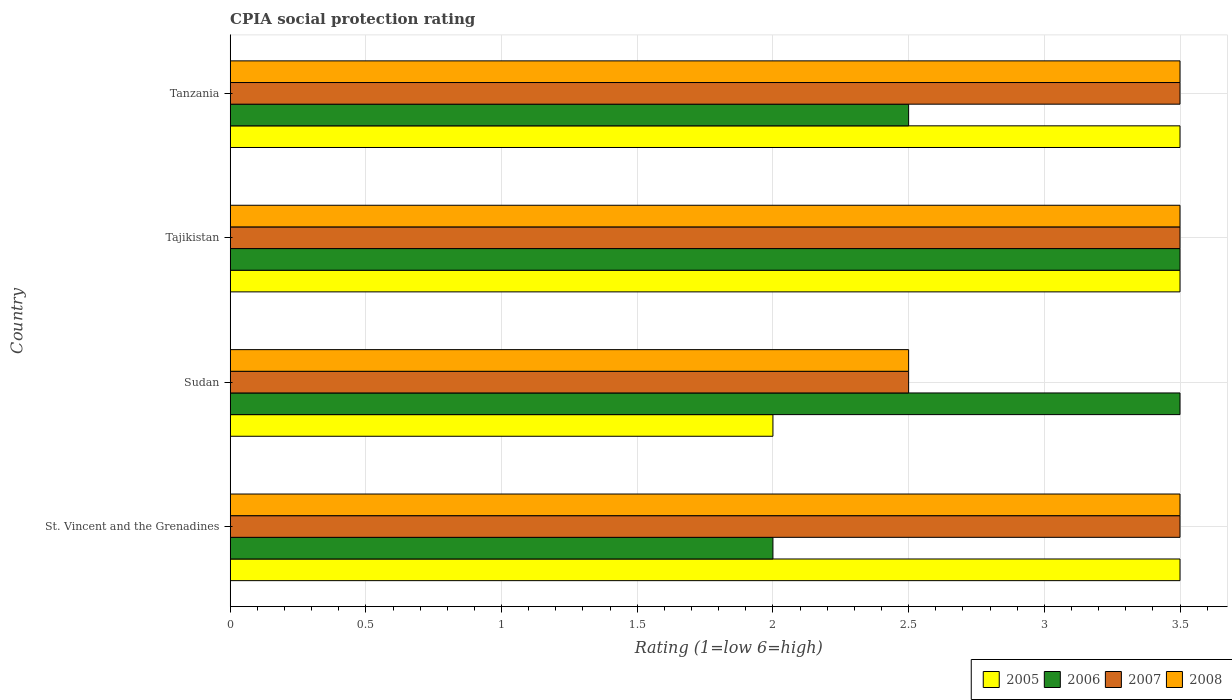How many different coloured bars are there?
Make the answer very short. 4. How many groups of bars are there?
Your response must be concise. 4. How many bars are there on the 2nd tick from the bottom?
Your response must be concise. 4. What is the label of the 3rd group of bars from the top?
Give a very brief answer. Sudan. What is the CPIA rating in 2007 in St. Vincent and the Grenadines?
Offer a very short reply. 3.5. In which country was the CPIA rating in 2008 maximum?
Your answer should be compact. St. Vincent and the Grenadines. In which country was the CPIA rating in 2008 minimum?
Keep it short and to the point. Sudan. What is the total CPIA rating in 2006 in the graph?
Provide a succinct answer. 11.5. What is the difference between the CPIA rating in 2006 in Tanzania and the CPIA rating in 2007 in St. Vincent and the Grenadines?
Provide a succinct answer. -1. What is the average CPIA rating in 2005 per country?
Give a very brief answer. 3.12. What is the difference between the CPIA rating in 2008 and CPIA rating in 2005 in Sudan?
Ensure brevity in your answer.  0.5. In how many countries, is the CPIA rating in 2006 greater than 0.1 ?
Your answer should be very brief. 4. What is the ratio of the CPIA rating in 2006 in Sudan to that in Tanzania?
Offer a very short reply. 1.4. Is the CPIA rating in 2006 in Sudan less than that in Tajikistan?
Provide a succinct answer. No. What is the difference between the highest and the second highest CPIA rating in 2007?
Your answer should be very brief. 0. What is the difference between the highest and the lowest CPIA rating in 2005?
Your response must be concise. 1.5. In how many countries, is the CPIA rating in 2007 greater than the average CPIA rating in 2007 taken over all countries?
Your response must be concise. 3. Is the sum of the CPIA rating in 2005 in St. Vincent and the Grenadines and Sudan greater than the maximum CPIA rating in 2008 across all countries?
Provide a succinct answer. Yes. Is it the case that in every country, the sum of the CPIA rating in 2006 and CPIA rating in 2005 is greater than the sum of CPIA rating in 2007 and CPIA rating in 2008?
Provide a succinct answer. No. Are all the bars in the graph horizontal?
Offer a terse response. Yes. Does the graph contain grids?
Keep it short and to the point. Yes. How are the legend labels stacked?
Provide a short and direct response. Horizontal. What is the title of the graph?
Ensure brevity in your answer.  CPIA social protection rating. What is the label or title of the X-axis?
Ensure brevity in your answer.  Rating (1=low 6=high). What is the label or title of the Y-axis?
Your answer should be very brief. Country. What is the Rating (1=low 6=high) of 2006 in St. Vincent and the Grenadines?
Offer a terse response. 2. What is the Rating (1=low 6=high) of 2007 in St. Vincent and the Grenadines?
Your answer should be very brief. 3.5. What is the Rating (1=low 6=high) in 2008 in St. Vincent and the Grenadines?
Provide a short and direct response. 3.5. What is the Rating (1=low 6=high) of 2005 in Sudan?
Your answer should be very brief. 2. What is the Rating (1=low 6=high) of 2006 in Sudan?
Ensure brevity in your answer.  3.5. What is the Rating (1=low 6=high) of 2006 in Tajikistan?
Provide a succinct answer. 3.5. What is the Rating (1=low 6=high) in 2007 in Tajikistan?
Make the answer very short. 3.5. What is the Rating (1=low 6=high) of 2008 in Tajikistan?
Your answer should be compact. 3.5. What is the Rating (1=low 6=high) in 2005 in Tanzania?
Provide a succinct answer. 3.5. Across all countries, what is the maximum Rating (1=low 6=high) of 2008?
Provide a succinct answer. 3.5. Across all countries, what is the minimum Rating (1=low 6=high) in 2005?
Your answer should be very brief. 2. What is the total Rating (1=low 6=high) of 2006 in the graph?
Make the answer very short. 11.5. What is the total Rating (1=low 6=high) of 2007 in the graph?
Your answer should be compact. 13. What is the total Rating (1=low 6=high) of 2008 in the graph?
Your response must be concise. 13. What is the difference between the Rating (1=low 6=high) in 2005 in St. Vincent and the Grenadines and that in Sudan?
Offer a very short reply. 1.5. What is the difference between the Rating (1=low 6=high) in 2006 in St. Vincent and the Grenadines and that in Sudan?
Your answer should be very brief. -1.5. What is the difference between the Rating (1=low 6=high) of 2007 in St. Vincent and the Grenadines and that in Sudan?
Make the answer very short. 1. What is the difference between the Rating (1=low 6=high) in 2007 in St. Vincent and the Grenadines and that in Tajikistan?
Give a very brief answer. 0. What is the difference between the Rating (1=low 6=high) in 2007 in St. Vincent and the Grenadines and that in Tanzania?
Ensure brevity in your answer.  0. What is the difference between the Rating (1=low 6=high) of 2005 in Sudan and that in Tajikistan?
Provide a succinct answer. -1.5. What is the difference between the Rating (1=low 6=high) in 2007 in Sudan and that in Tajikistan?
Give a very brief answer. -1. What is the difference between the Rating (1=low 6=high) of 2005 in Sudan and that in Tanzania?
Your answer should be compact. -1.5. What is the difference between the Rating (1=low 6=high) of 2005 in St. Vincent and the Grenadines and the Rating (1=low 6=high) of 2008 in Sudan?
Offer a very short reply. 1. What is the difference between the Rating (1=low 6=high) in 2006 in St. Vincent and the Grenadines and the Rating (1=low 6=high) in 2007 in Sudan?
Your response must be concise. -0.5. What is the difference between the Rating (1=low 6=high) of 2006 in St. Vincent and the Grenadines and the Rating (1=low 6=high) of 2008 in Sudan?
Your answer should be compact. -0.5. What is the difference between the Rating (1=low 6=high) of 2005 in St. Vincent and the Grenadines and the Rating (1=low 6=high) of 2006 in Tajikistan?
Your response must be concise. 0. What is the difference between the Rating (1=low 6=high) of 2005 in St. Vincent and the Grenadines and the Rating (1=low 6=high) of 2008 in Tajikistan?
Your response must be concise. 0. What is the difference between the Rating (1=low 6=high) of 2006 in St. Vincent and the Grenadines and the Rating (1=low 6=high) of 2007 in Tajikistan?
Ensure brevity in your answer.  -1.5. What is the difference between the Rating (1=low 6=high) of 2006 in St. Vincent and the Grenadines and the Rating (1=low 6=high) of 2008 in Tajikistan?
Ensure brevity in your answer.  -1.5. What is the difference between the Rating (1=low 6=high) of 2005 in St. Vincent and the Grenadines and the Rating (1=low 6=high) of 2007 in Tanzania?
Give a very brief answer. 0. What is the difference between the Rating (1=low 6=high) in 2005 in St. Vincent and the Grenadines and the Rating (1=low 6=high) in 2008 in Tanzania?
Give a very brief answer. 0. What is the difference between the Rating (1=low 6=high) in 2006 in St. Vincent and the Grenadines and the Rating (1=low 6=high) in 2007 in Tanzania?
Ensure brevity in your answer.  -1.5. What is the difference between the Rating (1=low 6=high) in 2007 in St. Vincent and the Grenadines and the Rating (1=low 6=high) in 2008 in Tanzania?
Your answer should be very brief. 0. What is the difference between the Rating (1=low 6=high) in 2005 in Sudan and the Rating (1=low 6=high) in 2006 in Tajikistan?
Keep it short and to the point. -1.5. What is the difference between the Rating (1=low 6=high) of 2005 in Sudan and the Rating (1=low 6=high) of 2007 in Tajikistan?
Offer a very short reply. -1.5. What is the difference between the Rating (1=low 6=high) of 2006 in Sudan and the Rating (1=low 6=high) of 2007 in Tajikistan?
Ensure brevity in your answer.  0. What is the difference between the Rating (1=low 6=high) of 2006 in Sudan and the Rating (1=low 6=high) of 2008 in Tajikistan?
Provide a succinct answer. 0. What is the difference between the Rating (1=low 6=high) in 2007 in Sudan and the Rating (1=low 6=high) in 2008 in Tajikistan?
Ensure brevity in your answer.  -1. What is the difference between the Rating (1=low 6=high) in 2005 in Sudan and the Rating (1=low 6=high) in 2007 in Tanzania?
Ensure brevity in your answer.  -1.5. What is the difference between the Rating (1=low 6=high) of 2006 in Sudan and the Rating (1=low 6=high) of 2007 in Tanzania?
Keep it short and to the point. 0. What is the difference between the Rating (1=low 6=high) in 2006 in Sudan and the Rating (1=low 6=high) in 2008 in Tanzania?
Offer a very short reply. 0. What is the difference between the Rating (1=low 6=high) of 2007 in Sudan and the Rating (1=low 6=high) of 2008 in Tanzania?
Provide a succinct answer. -1. What is the difference between the Rating (1=low 6=high) of 2005 in Tajikistan and the Rating (1=low 6=high) of 2007 in Tanzania?
Offer a very short reply. 0. What is the difference between the Rating (1=low 6=high) of 2006 in Tajikistan and the Rating (1=low 6=high) of 2007 in Tanzania?
Your response must be concise. 0. What is the difference between the Rating (1=low 6=high) of 2006 in Tajikistan and the Rating (1=low 6=high) of 2008 in Tanzania?
Your response must be concise. 0. What is the average Rating (1=low 6=high) in 2005 per country?
Keep it short and to the point. 3.12. What is the average Rating (1=low 6=high) in 2006 per country?
Your answer should be compact. 2.88. What is the average Rating (1=low 6=high) in 2008 per country?
Your answer should be compact. 3.25. What is the difference between the Rating (1=low 6=high) in 2005 and Rating (1=low 6=high) in 2006 in St. Vincent and the Grenadines?
Ensure brevity in your answer.  1.5. What is the difference between the Rating (1=low 6=high) in 2005 and Rating (1=low 6=high) in 2008 in St. Vincent and the Grenadines?
Provide a succinct answer. 0. What is the difference between the Rating (1=low 6=high) in 2006 and Rating (1=low 6=high) in 2007 in Sudan?
Your answer should be compact. 1. What is the difference between the Rating (1=low 6=high) in 2006 and Rating (1=low 6=high) in 2008 in Sudan?
Offer a very short reply. 1. What is the difference between the Rating (1=low 6=high) of 2007 and Rating (1=low 6=high) of 2008 in Sudan?
Offer a terse response. 0. What is the difference between the Rating (1=low 6=high) in 2005 and Rating (1=low 6=high) in 2007 in Tajikistan?
Your answer should be compact. 0. What is the difference between the Rating (1=low 6=high) in 2005 and Rating (1=low 6=high) in 2008 in Tajikistan?
Your response must be concise. 0. What is the difference between the Rating (1=low 6=high) in 2006 and Rating (1=low 6=high) in 2007 in Tajikistan?
Ensure brevity in your answer.  0. What is the difference between the Rating (1=low 6=high) of 2006 and Rating (1=low 6=high) of 2008 in Tajikistan?
Ensure brevity in your answer.  0. What is the difference between the Rating (1=low 6=high) of 2005 and Rating (1=low 6=high) of 2007 in Tanzania?
Offer a very short reply. 0. What is the difference between the Rating (1=low 6=high) of 2005 and Rating (1=low 6=high) of 2008 in Tanzania?
Offer a very short reply. 0. What is the difference between the Rating (1=low 6=high) of 2006 and Rating (1=low 6=high) of 2007 in Tanzania?
Provide a succinct answer. -1. What is the difference between the Rating (1=low 6=high) in 2006 and Rating (1=low 6=high) in 2008 in Tanzania?
Your answer should be very brief. -1. What is the ratio of the Rating (1=low 6=high) in 2005 in St. Vincent and the Grenadines to that in Sudan?
Provide a succinct answer. 1.75. What is the ratio of the Rating (1=low 6=high) of 2006 in St. Vincent and the Grenadines to that in Sudan?
Provide a short and direct response. 0.57. What is the ratio of the Rating (1=low 6=high) in 2007 in St. Vincent and the Grenadines to that in Sudan?
Offer a very short reply. 1.4. What is the ratio of the Rating (1=low 6=high) in 2008 in St. Vincent and the Grenadines to that in Sudan?
Provide a short and direct response. 1.4. What is the ratio of the Rating (1=low 6=high) of 2005 in St. Vincent and the Grenadines to that in Tajikistan?
Give a very brief answer. 1. What is the ratio of the Rating (1=low 6=high) in 2006 in St. Vincent and the Grenadines to that in Tanzania?
Your answer should be very brief. 0.8. What is the ratio of the Rating (1=low 6=high) in 2008 in St. Vincent and the Grenadines to that in Tanzania?
Offer a terse response. 1. What is the ratio of the Rating (1=low 6=high) in 2005 in Sudan to that in Tajikistan?
Your response must be concise. 0.57. What is the ratio of the Rating (1=low 6=high) in 2007 in Sudan to that in Tajikistan?
Offer a terse response. 0.71. What is the ratio of the Rating (1=low 6=high) of 2007 in Sudan to that in Tanzania?
Provide a short and direct response. 0.71. What is the ratio of the Rating (1=low 6=high) in 2008 in Sudan to that in Tanzania?
Your answer should be very brief. 0.71. What is the ratio of the Rating (1=low 6=high) of 2006 in Tajikistan to that in Tanzania?
Your answer should be compact. 1.4. What is the ratio of the Rating (1=low 6=high) of 2007 in Tajikistan to that in Tanzania?
Make the answer very short. 1. What is the ratio of the Rating (1=low 6=high) in 2008 in Tajikistan to that in Tanzania?
Your answer should be very brief. 1. What is the difference between the highest and the second highest Rating (1=low 6=high) in 2005?
Keep it short and to the point. 0. What is the difference between the highest and the second highest Rating (1=low 6=high) in 2006?
Your answer should be compact. 0. What is the difference between the highest and the lowest Rating (1=low 6=high) in 2005?
Offer a terse response. 1.5. What is the difference between the highest and the lowest Rating (1=low 6=high) in 2006?
Provide a short and direct response. 1.5. What is the difference between the highest and the lowest Rating (1=low 6=high) of 2008?
Make the answer very short. 1. 